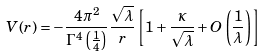Convert formula to latex. <formula><loc_0><loc_0><loc_500><loc_500>V ( r ) = - \frac { 4 \pi ^ { 2 } } { \Gamma ^ { 4 } \left ( \frac { 1 } { 4 } \right ) } \frac { \sqrt { \lambda } } { r } \left [ 1 + \frac { \kappa } { \sqrt { \lambda } } + O \left ( \frac { 1 } { \lambda } \right ) \right ]</formula> 